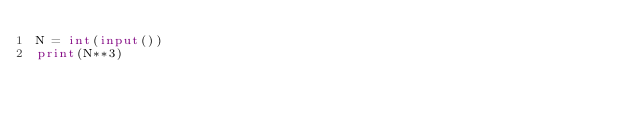Convert code to text. <code><loc_0><loc_0><loc_500><loc_500><_Python_>N = int(input())
print(N**3)</code> 